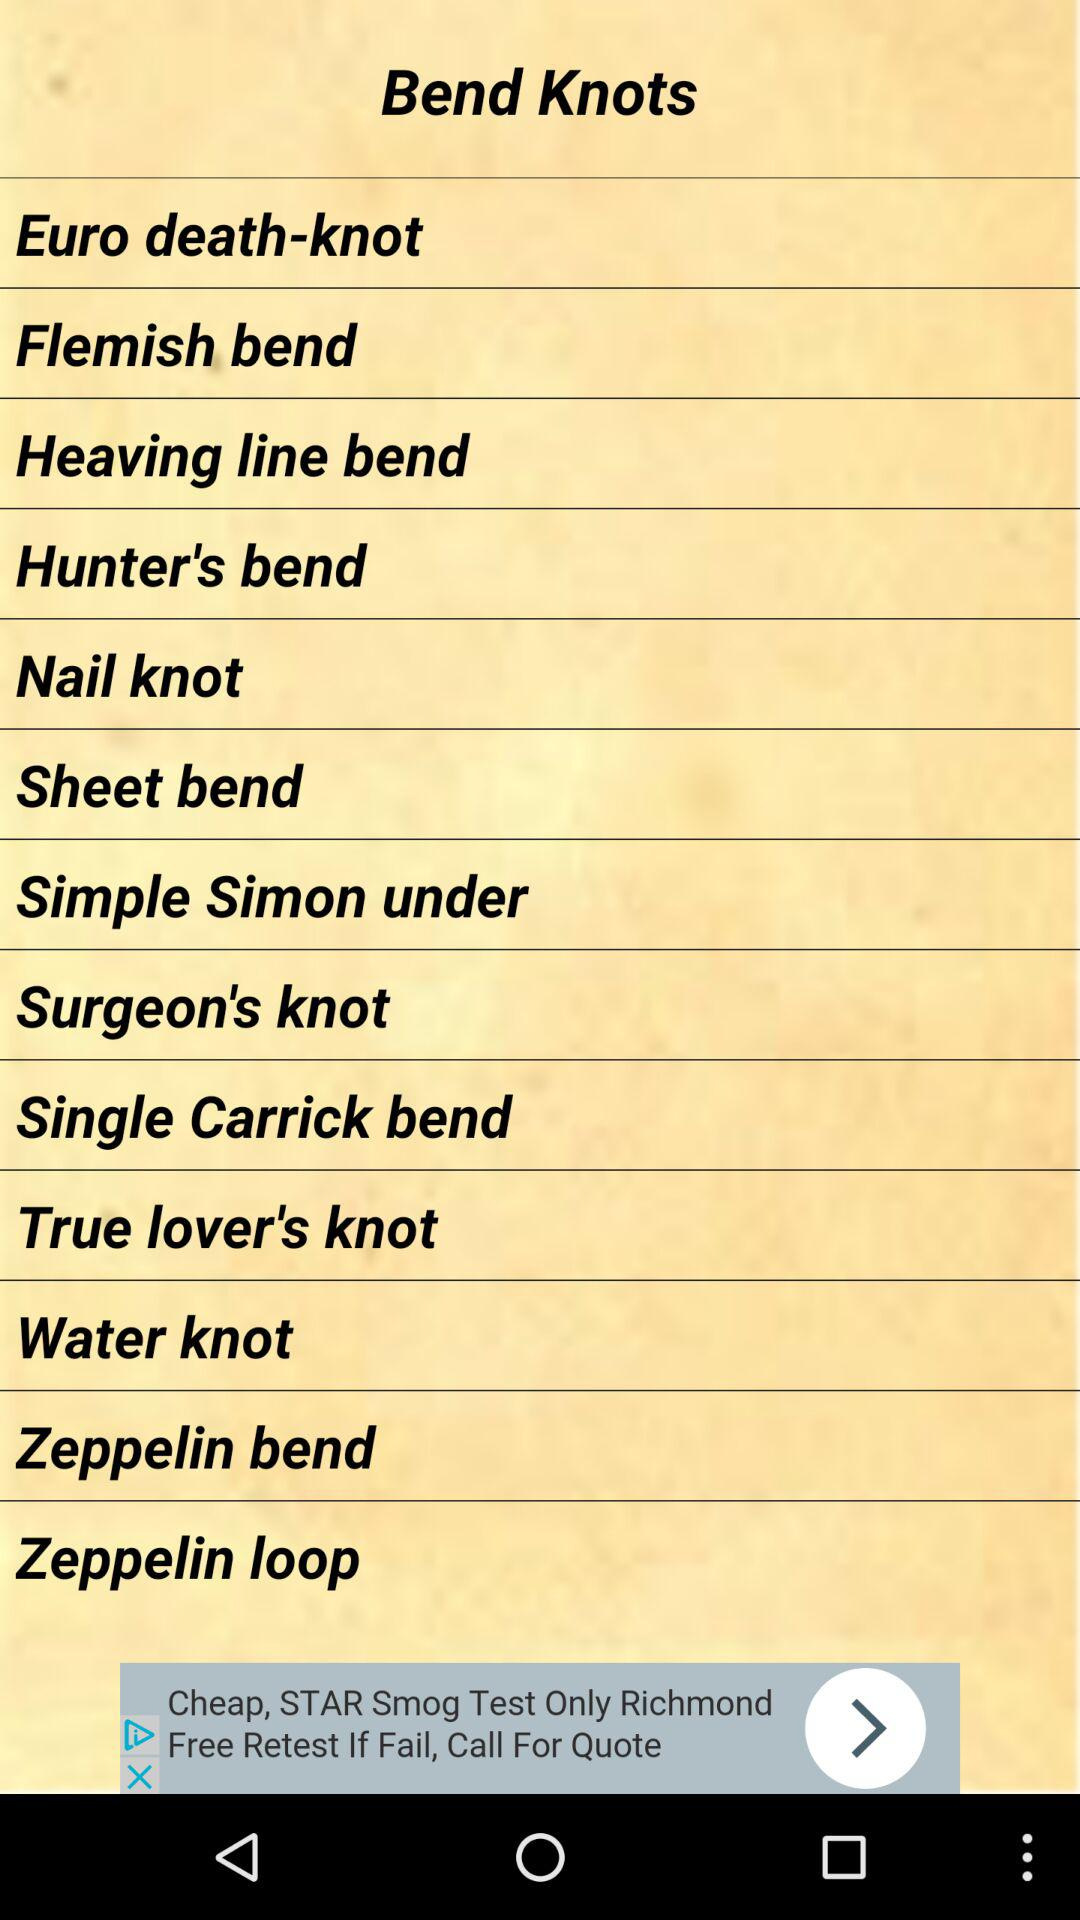What are the names of the different knots? The names of the different knots are "Euro death-knot", "Flemish bend", "Heaving line bend", "Hunter's bend", "Nail knot", "Sheet bend", "Simple Simon under", "Surgeon's knot", "Single Carrick bend", "True lover's knot", "Water knot", "Zeppelin bend" and "Zeppelin loop". 